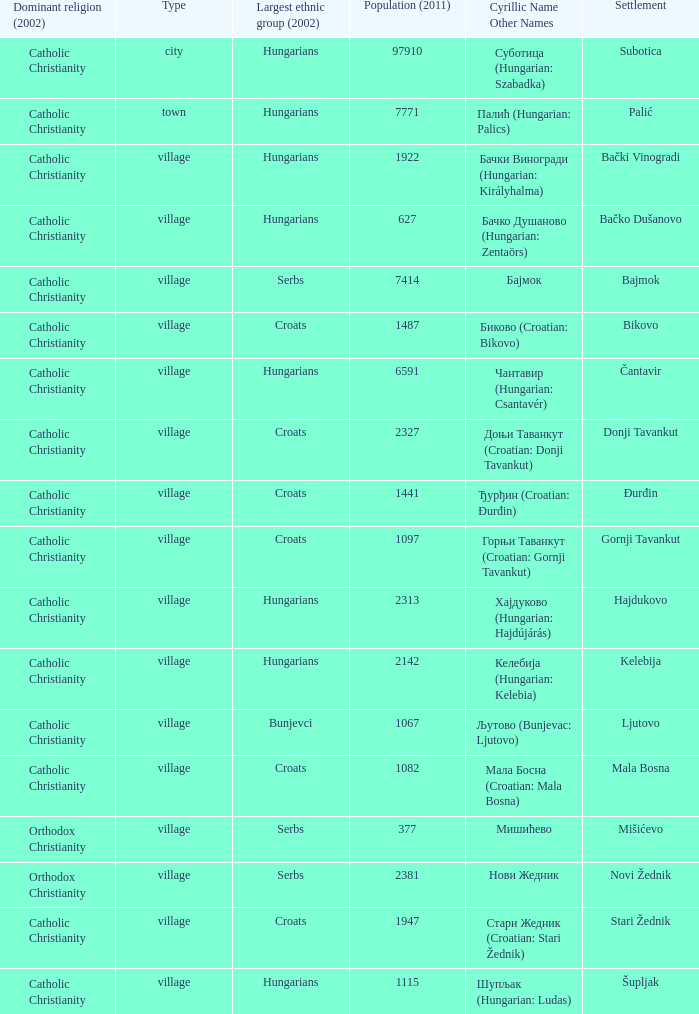What type of settlement has a population of 1441? Village. Help me parse the entirety of this table. {'header': ['Dominant religion (2002)', 'Type', 'Largest ethnic group (2002)', 'Population (2011)', 'Cyrillic Name Other Names', 'Settlement'], 'rows': [['Catholic Christianity', 'city', 'Hungarians', '97910', 'Суботица (Hungarian: Szabadka)', 'Subotica'], ['Catholic Christianity', 'town', 'Hungarians', '7771', 'Палић (Hungarian: Palics)', 'Palić'], ['Catholic Christianity', 'village', 'Hungarians', '1922', 'Бачки Виногради (Hungarian: Királyhalma)', 'Bački Vinogradi'], ['Catholic Christianity', 'village', 'Hungarians', '627', 'Бачко Душаново (Hungarian: Zentaörs)', 'Bačko Dušanovo'], ['Catholic Christianity', 'village', 'Serbs', '7414', 'Бајмок', 'Bajmok'], ['Catholic Christianity', 'village', 'Croats', '1487', 'Биково (Croatian: Bikovo)', 'Bikovo'], ['Catholic Christianity', 'village', 'Hungarians', '6591', 'Чантавир (Hungarian: Csantavér)', 'Čantavir'], ['Catholic Christianity', 'village', 'Croats', '2327', 'Доњи Таванкут (Croatian: Donji Tavankut)', 'Donji Tavankut'], ['Catholic Christianity', 'village', 'Croats', '1441', 'Ђурђин (Croatian: Đurđin)', 'Đurđin'], ['Catholic Christianity', 'village', 'Croats', '1097', 'Горњи Таванкут (Croatian: Gornji Tavankut)', 'Gornji Tavankut'], ['Catholic Christianity', 'village', 'Hungarians', '2313', 'Хајдуково (Hungarian: Hajdújárás)', 'Hajdukovo'], ['Catholic Christianity', 'village', 'Hungarians', '2142', 'Келебија (Hungarian: Kelebia)', 'Kelebija'], ['Catholic Christianity', 'village', 'Bunjevci', '1067', 'Љутово (Bunjevac: Ljutovo)', 'Ljutovo'], ['Catholic Christianity', 'village', 'Croats', '1082', 'Мала Босна (Croatian: Mala Bosna)', 'Mala Bosna'], ['Orthodox Christianity', 'village', 'Serbs', '377', 'Мишићево', 'Mišićevo'], ['Orthodox Christianity', 'village', 'Serbs', '2381', 'Нови Жедник', 'Novi Žednik'], ['Catholic Christianity', 'village', 'Croats', '1947', 'Стари Жедник (Croatian: Stari Žednik)', 'Stari Žednik'], ['Catholic Christianity', 'village', 'Hungarians', '1115', 'Шупљак (Hungarian: Ludas)', 'Šupljak']]} 